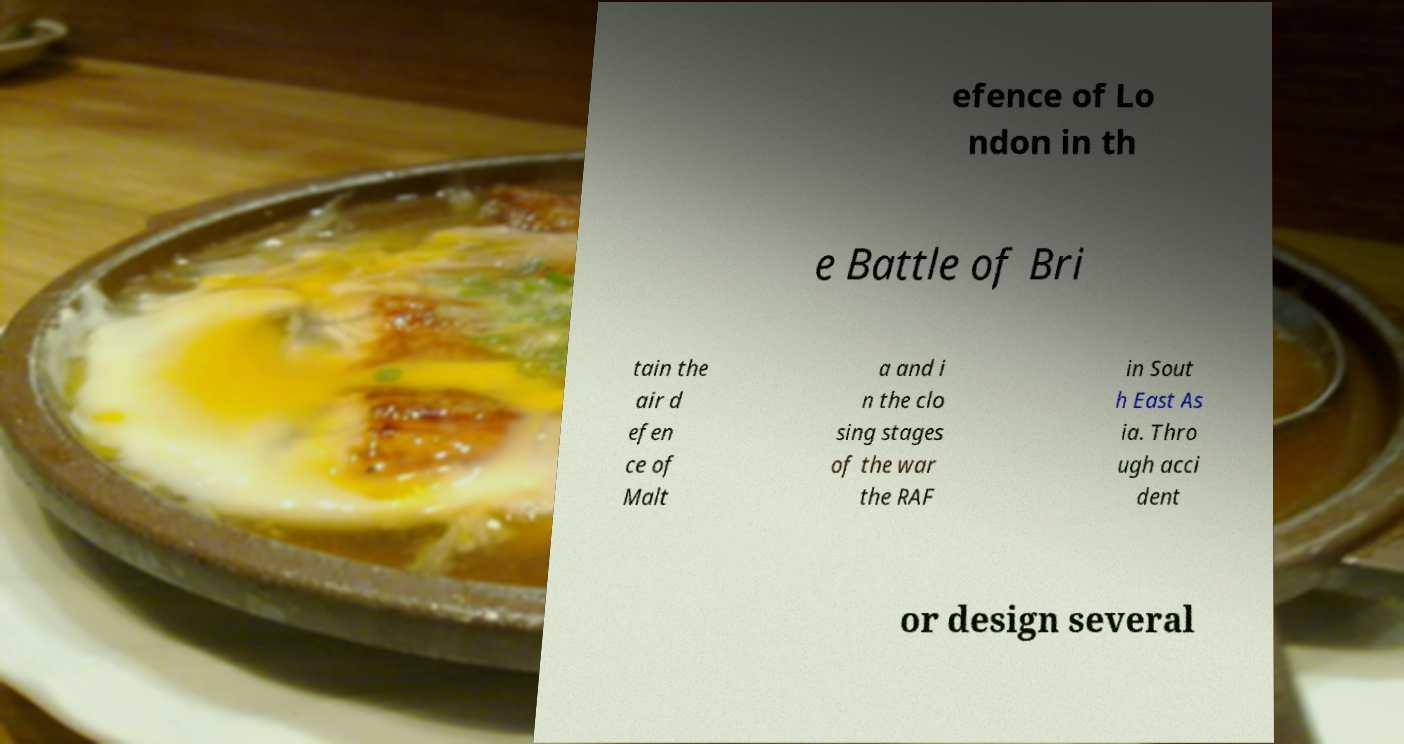For documentation purposes, I need the text within this image transcribed. Could you provide that? efence of Lo ndon in th e Battle of Bri tain the air d efen ce of Malt a and i n the clo sing stages of the war the RAF in Sout h East As ia. Thro ugh acci dent or design several 